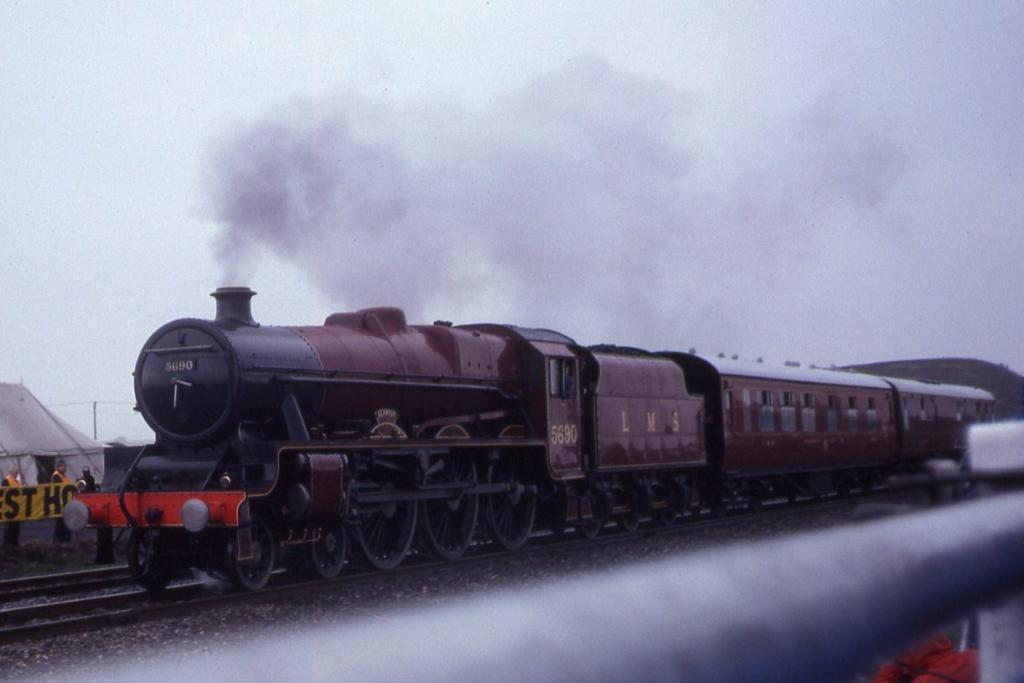What is the main subject of the image? The main subject of the image is a train. What is the train doing in the image? The train is moving on a railway track. Can you describe the train's appearance? The train is emitting smoke from the top. What else can be seen in the image besides the train? There is a tent in the image, and two people are standing outside the tent. Where is the tent located in relation to the train? The tent is behind the train. What impulse does the side of the train have in the image? There is no mention of an impulse or the side of the train in the image. The train is simply moving on a railway track, emitting smoke from the top. 